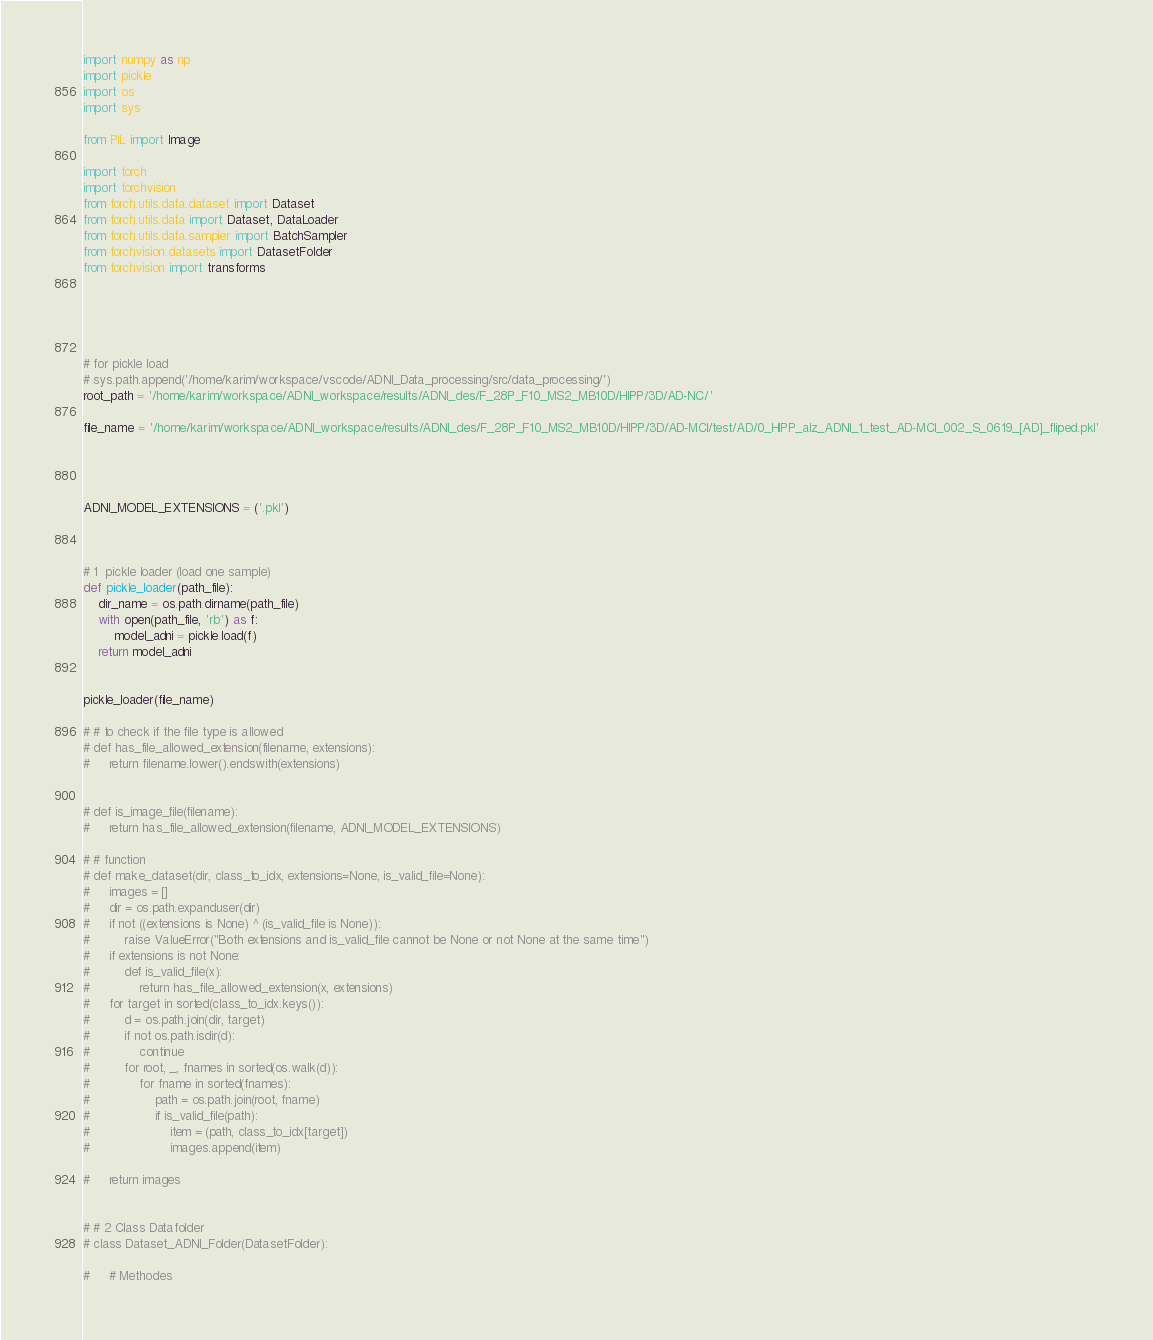<code> <loc_0><loc_0><loc_500><loc_500><_Python_>
import numpy as np
import pickle
import os
import sys

from PIL import Image

import torch
import torchvision
from torch.utils.data.dataset import Dataset
from torch.utils.data import Dataset, DataLoader
from torch.utils.data.sampler import BatchSampler
from torchvision.datasets import DatasetFolder
from torchvision import transforms





# for pickle load
# sys.path.append('/home/karim/workspace/vscode/ADNI_Data_processing/src/data_processing/')
root_path = '/home/karim/workspace/ADNI_workspace/results/ADNI_des/F_28P_F10_MS2_MB10D/HIPP/3D/AD-NC/'

file_name = '/home/karim/workspace/ADNI_workspace/results/ADNI_des/F_28P_F10_MS2_MB10D/HIPP/3D/AD-MCI/test/AD/0_HIPP_alz_ADNI_1_test_AD-MCI_002_S_0619_[AD]_fliped.pkl'




ADNI_MODEL_EXTENSIONS = ('.pkl')



# 1  pickle loader (load one sample)
def pickle_loader(path_file):    
    dir_name = os.path.dirname(path_file)
    with open(path_file, 'rb') as f:
        model_adni = pickle.load(f)
    return model_adni


pickle_loader(file_name)

# # to check if the file type is allowed 
# def has_file_allowed_extension(filename, extensions):
#     return filename.lower().endswith(extensions)


# def is_image_file(filename):
#     return has_file_allowed_extension(filename, ADNI_MODEL_EXTENSIONS)

# # function 
# def make_dataset(dir, class_to_idx, extensions=None, is_valid_file=None):
#     images = []
#     dir = os.path.expanduser(dir)
#     if not ((extensions is None) ^ (is_valid_file is None)):
#         raise ValueError("Both extensions and is_valid_file cannot be None or not None at the same time")
#     if extensions is not None:
#         def is_valid_file(x):
#             return has_file_allowed_extension(x, extensions)
#     for target in sorted(class_to_idx.keys()):
#         d = os.path.join(dir, target)
#         if not os.path.isdir(d):
#             continue
#         for root, _, fnames in sorted(os.walk(d)):
#             for fname in sorted(fnames):
#                 path = os.path.join(root, fname)
#                 if is_valid_file(path):
#                     item = (path, class_to_idx[target])
#                     images.append(item)

#     return images


# # 2 Class Datafolder
# class Dataset_ADNI_Folder(DatasetFolder):  

#     # Methodes</code> 